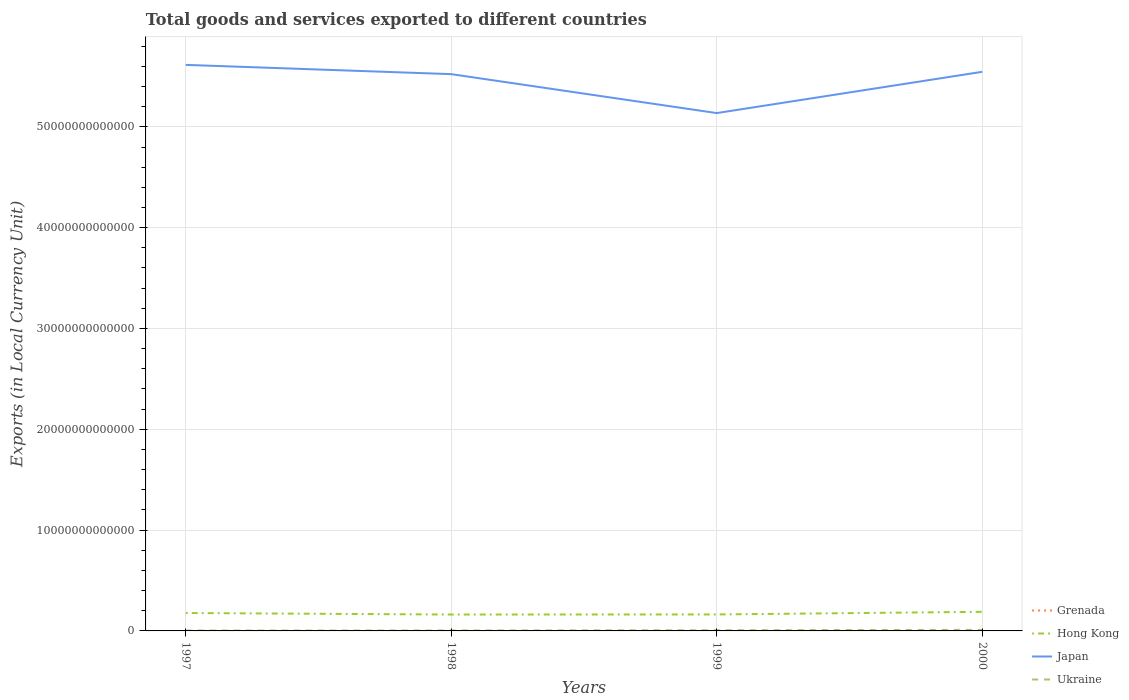Does the line corresponding to Ukraine intersect with the line corresponding to Hong Kong?
Your answer should be compact. No. Is the number of lines equal to the number of legend labels?
Provide a short and direct response. Yes. Across all years, what is the maximum Amount of goods and services exports in Ukraine?
Give a very brief answer. 3.79e+1. In which year was the Amount of goods and services exports in Japan maximum?
Your answer should be compact. 1999. What is the total Amount of goods and services exports in Ukraine in the graph?
Ensure brevity in your answer.  -6.83e+1. What is the difference between the highest and the second highest Amount of goods and services exports in Grenada?
Provide a succinct answer. 2.74e+08. Is the Amount of goods and services exports in Grenada strictly greater than the Amount of goods and services exports in Ukraine over the years?
Ensure brevity in your answer.  Yes. How many lines are there?
Keep it short and to the point. 4. What is the difference between two consecutive major ticks on the Y-axis?
Offer a very short reply. 1.00e+13. Does the graph contain grids?
Offer a very short reply. Yes. Where does the legend appear in the graph?
Your answer should be compact. Bottom right. How many legend labels are there?
Provide a succinct answer. 4. How are the legend labels stacked?
Give a very brief answer. Vertical. What is the title of the graph?
Keep it short and to the point. Total goods and services exported to different countries. Does "Croatia" appear as one of the legend labels in the graph?
Offer a terse response. No. What is the label or title of the X-axis?
Give a very brief answer. Years. What is the label or title of the Y-axis?
Offer a terse response. Exports (in Local Currency Unit). What is the Exports (in Local Currency Unit) of Grenada in 1997?
Provide a short and direct response. 3.62e+08. What is the Exports (in Local Currency Unit) in Hong Kong in 1997?
Your response must be concise. 1.78e+12. What is the Exports (in Local Currency Unit) in Japan in 1997?
Offer a very short reply. 5.61e+13. What is the Exports (in Local Currency Unit) in Ukraine in 1997?
Your answer should be compact. 3.79e+1. What is the Exports (in Local Currency Unit) of Grenada in 1998?
Your answer should be compact. 4.25e+08. What is the Exports (in Local Currency Unit) of Hong Kong in 1998?
Ensure brevity in your answer.  1.63e+12. What is the Exports (in Local Currency Unit) in Japan in 1998?
Provide a short and direct response. 5.52e+13. What is the Exports (in Local Currency Unit) of Ukraine in 1998?
Keep it short and to the point. 4.30e+1. What is the Exports (in Local Currency Unit) in Grenada in 1999?
Your answer should be very brief. 5.89e+08. What is the Exports (in Local Currency Unit) in Hong Kong in 1999?
Your answer should be compact. 1.63e+12. What is the Exports (in Local Currency Unit) of Japan in 1999?
Your answer should be very brief. 5.14e+13. What is the Exports (in Local Currency Unit) of Ukraine in 1999?
Make the answer very short. 7.01e+1. What is the Exports (in Local Currency Unit) in Grenada in 2000?
Your response must be concise. 6.36e+08. What is the Exports (in Local Currency Unit) of Hong Kong in 2000?
Ensure brevity in your answer.  1.90e+12. What is the Exports (in Local Currency Unit) of Japan in 2000?
Your response must be concise. 5.55e+13. What is the Exports (in Local Currency Unit) in Ukraine in 2000?
Make the answer very short. 1.06e+11. Across all years, what is the maximum Exports (in Local Currency Unit) in Grenada?
Provide a succinct answer. 6.36e+08. Across all years, what is the maximum Exports (in Local Currency Unit) in Hong Kong?
Offer a terse response. 1.90e+12. Across all years, what is the maximum Exports (in Local Currency Unit) in Japan?
Provide a succinct answer. 5.61e+13. Across all years, what is the maximum Exports (in Local Currency Unit) of Ukraine?
Provide a short and direct response. 1.06e+11. Across all years, what is the minimum Exports (in Local Currency Unit) in Grenada?
Make the answer very short. 3.62e+08. Across all years, what is the minimum Exports (in Local Currency Unit) of Hong Kong?
Offer a very short reply. 1.63e+12. Across all years, what is the minimum Exports (in Local Currency Unit) in Japan?
Provide a short and direct response. 5.14e+13. Across all years, what is the minimum Exports (in Local Currency Unit) of Ukraine?
Offer a very short reply. 3.79e+1. What is the total Exports (in Local Currency Unit) of Grenada in the graph?
Make the answer very short. 2.01e+09. What is the total Exports (in Local Currency Unit) in Hong Kong in the graph?
Give a very brief answer. 6.93e+12. What is the total Exports (in Local Currency Unit) of Japan in the graph?
Your answer should be compact. 2.18e+14. What is the total Exports (in Local Currency Unit) of Ukraine in the graph?
Give a very brief answer. 2.57e+11. What is the difference between the Exports (in Local Currency Unit) in Grenada in 1997 and that in 1998?
Keep it short and to the point. -6.30e+07. What is the difference between the Exports (in Local Currency Unit) of Hong Kong in 1997 and that in 1998?
Give a very brief answer. 1.50e+11. What is the difference between the Exports (in Local Currency Unit) in Japan in 1997 and that in 1998?
Offer a terse response. 9.19e+11. What is the difference between the Exports (in Local Currency Unit) in Ukraine in 1997 and that in 1998?
Give a very brief answer. -5.08e+09. What is the difference between the Exports (in Local Currency Unit) of Grenada in 1997 and that in 1999?
Ensure brevity in your answer.  -2.27e+08. What is the difference between the Exports (in Local Currency Unit) of Hong Kong in 1997 and that in 1999?
Keep it short and to the point. 1.42e+11. What is the difference between the Exports (in Local Currency Unit) in Japan in 1997 and that in 1999?
Offer a terse response. 4.78e+12. What is the difference between the Exports (in Local Currency Unit) in Ukraine in 1997 and that in 1999?
Your answer should be very brief. -3.22e+1. What is the difference between the Exports (in Local Currency Unit) of Grenada in 1997 and that in 2000?
Offer a very short reply. -2.74e+08. What is the difference between the Exports (in Local Currency Unit) in Hong Kong in 1997 and that in 2000?
Offer a very short reply. -1.20e+11. What is the difference between the Exports (in Local Currency Unit) in Japan in 1997 and that in 2000?
Offer a very short reply. 6.87e+11. What is the difference between the Exports (in Local Currency Unit) of Ukraine in 1997 and that in 2000?
Your answer should be compact. -6.83e+1. What is the difference between the Exports (in Local Currency Unit) of Grenada in 1998 and that in 1999?
Your answer should be very brief. -1.64e+08. What is the difference between the Exports (in Local Currency Unit) of Hong Kong in 1998 and that in 1999?
Ensure brevity in your answer.  -7.95e+09. What is the difference between the Exports (in Local Currency Unit) in Japan in 1998 and that in 1999?
Your answer should be compact. 3.86e+12. What is the difference between the Exports (in Local Currency Unit) of Ukraine in 1998 and that in 1999?
Keep it short and to the point. -2.71e+1. What is the difference between the Exports (in Local Currency Unit) of Grenada in 1998 and that in 2000?
Your answer should be compact. -2.11e+08. What is the difference between the Exports (in Local Currency Unit) of Hong Kong in 1998 and that in 2000?
Provide a short and direct response. -2.71e+11. What is the difference between the Exports (in Local Currency Unit) in Japan in 1998 and that in 2000?
Make the answer very short. -2.32e+11. What is the difference between the Exports (in Local Currency Unit) in Ukraine in 1998 and that in 2000?
Make the answer very short. -6.32e+1. What is the difference between the Exports (in Local Currency Unit) in Grenada in 1999 and that in 2000?
Make the answer very short. -4.78e+07. What is the difference between the Exports (in Local Currency Unit) in Hong Kong in 1999 and that in 2000?
Your answer should be compact. -2.63e+11. What is the difference between the Exports (in Local Currency Unit) in Japan in 1999 and that in 2000?
Provide a short and direct response. -4.09e+12. What is the difference between the Exports (in Local Currency Unit) in Ukraine in 1999 and that in 2000?
Give a very brief answer. -3.61e+1. What is the difference between the Exports (in Local Currency Unit) of Grenada in 1997 and the Exports (in Local Currency Unit) of Hong Kong in 1998?
Offer a very short reply. -1.63e+12. What is the difference between the Exports (in Local Currency Unit) in Grenada in 1997 and the Exports (in Local Currency Unit) in Japan in 1998?
Your response must be concise. -5.52e+13. What is the difference between the Exports (in Local Currency Unit) of Grenada in 1997 and the Exports (in Local Currency Unit) of Ukraine in 1998?
Provide a short and direct response. -4.26e+1. What is the difference between the Exports (in Local Currency Unit) in Hong Kong in 1997 and the Exports (in Local Currency Unit) in Japan in 1998?
Your answer should be very brief. -5.35e+13. What is the difference between the Exports (in Local Currency Unit) of Hong Kong in 1997 and the Exports (in Local Currency Unit) of Ukraine in 1998?
Provide a short and direct response. 1.73e+12. What is the difference between the Exports (in Local Currency Unit) of Japan in 1997 and the Exports (in Local Currency Unit) of Ukraine in 1998?
Provide a succinct answer. 5.61e+13. What is the difference between the Exports (in Local Currency Unit) of Grenada in 1997 and the Exports (in Local Currency Unit) of Hong Kong in 1999?
Offer a terse response. -1.63e+12. What is the difference between the Exports (in Local Currency Unit) in Grenada in 1997 and the Exports (in Local Currency Unit) in Japan in 1999?
Provide a short and direct response. -5.14e+13. What is the difference between the Exports (in Local Currency Unit) of Grenada in 1997 and the Exports (in Local Currency Unit) of Ukraine in 1999?
Provide a short and direct response. -6.97e+1. What is the difference between the Exports (in Local Currency Unit) in Hong Kong in 1997 and the Exports (in Local Currency Unit) in Japan in 1999?
Your response must be concise. -4.96e+13. What is the difference between the Exports (in Local Currency Unit) of Hong Kong in 1997 and the Exports (in Local Currency Unit) of Ukraine in 1999?
Provide a short and direct response. 1.71e+12. What is the difference between the Exports (in Local Currency Unit) in Japan in 1997 and the Exports (in Local Currency Unit) in Ukraine in 1999?
Provide a short and direct response. 5.61e+13. What is the difference between the Exports (in Local Currency Unit) in Grenada in 1997 and the Exports (in Local Currency Unit) in Hong Kong in 2000?
Ensure brevity in your answer.  -1.90e+12. What is the difference between the Exports (in Local Currency Unit) of Grenada in 1997 and the Exports (in Local Currency Unit) of Japan in 2000?
Your response must be concise. -5.55e+13. What is the difference between the Exports (in Local Currency Unit) of Grenada in 1997 and the Exports (in Local Currency Unit) of Ukraine in 2000?
Offer a terse response. -1.06e+11. What is the difference between the Exports (in Local Currency Unit) in Hong Kong in 1997 and the Exports (in Local Currency Unit) in Japan in 2000?
Provide a short and direct response. -5.37e+13. What is the difference between the Exports (in Local Currency Unit) in Hong Kong in 1997 and the Exports (in Local Currency Unit) in Ukraine in 2000?
Offer a terse response. 1.67e+12. What is the difference between the Exports (in Local Currency Unit) in Japan in 1997 and the Exports (in Local Currency Unit) in Ukraine in 2000?
Provide a succinct answer. 5.60e+13. What is the difference between the Exports (in Local Currency Unit) in Grenada in 1998 and the Exports (in Local Currency Unit) in Hong Kong in 1999?
Your response must be concise. -1.63e+12. What is the difference between the Exports (in Local Currency Unit) of Grenada in 1998 and the Exports (in Local Currency Unit) of Japan in 1999?
Your response must be concise. -5.14e+13. What is the difference between the Exports (in Local Currency Unit) of Grenada in 1998 and the Exports (in Local Currency Unit) of Ukraine in 1999?
Provide a succinct answer. -6.96e+1. What is the difference between the Exports (in Local Currency Unit) in Hong Kong in 1998 and the Exports (in Local Currency Unit) in Japan in 1999?
Offer a very short reply. -4.97e+13. What is the difference between the Exports (in Local Currency Unit) in Hong Kong in 1998 and the Exports (in Local Currency Unit) in Ukraine in 1999?
Your response must be concise. 1.56e+12. What is the difference between the Exports (in Local Currency Unit) in Japan in 1998 and the Exports (in Local Currency Unit) in Ukraine in 1999?
Your answer should be very brief. 5.52e+13. What is the difference between the Exports (in Local Currency Unit) in Grenada in 1998 and the Exports (in Local Currency Unit) in Hong Kong in 2000?
Provide a short and direct response. -1.90e+12. What is the difference between the Exports (in Local Currency Unit) in Grenada in 1998 and the Exports (in Local Currency Unit) in Japan in 2000?
Make the answer very short. -5.55e+13. What is the difference between the Exports (in Local Currency Unit) in Grenada in 1998 and the Exports (in Local Currency Unit) in Ukraine in 2000?
Your response must be concise. -1.06e+11. What is the difference between the Exports (in Local Currency Unit) of Hong Kong in 1998 and the Exports (in Local Currency Unit) of Japan in 2000?
Your response must be concise. -5.38e+13. What is the difference between the Exports (in Local Currency Unit) of Hong Kong in 1998 and the Exports (in Local Currency Unit) of Ukraine in 2000?
Your answer should be compact. 1.52e+12. What is the difference between the Exports (in Local Currency Unit) of Japan in 1998 and the Exports (in Local Currency Unit) of Ukraine in 2000?
Offer a terse response. 5.51e+13. What is the difference between the Exports (in Local Currency Unit) of Grenada in 1999 and the Exports (in Local Currency Unit) of Hong Kong in 2000?
Your answer should be very brief. -1.90e+12. What is the difference between the Exports (in Local Currency Unit) in Grenada in 1999 and the Exports (in Local Currency Unit) in Japan in 2000?
Offer a terse response. -5.55e+13. What is the difference between the Exports (in Local Currency Unit) of Grenada in 1999 and the Exports (in Local Currency Unit) of Ukraine in 2000?
Offer a very short reply. -1.06e+11. What is the difference between the Exports (in Local Currency Unit) in Hong Kong in 1999 and the Exports (in Local Currency Unit) in Japan in 2000?
Offer a terse response. -5.38e+13. What is the difference between the Exports (in Local Currency Unit) of Hong Kong in 1999 and the Exports (in Local Currency Unit) of Ukraine in 2000?
Ensure brevity in your answer.  1.53e+12. What is the difference between the Exports (in Local Currency Unit) of Japan in 1999 and the Exports (in Local Currency Unit) of Ukraine in 2000?
Your response must be concise. 5.13e+13. What is the average Exports (in Local Currency Unit) of Grenada per year?
Provide a short and direct response. 5.03e+08. What is the average Exports (in Local Currency Unit) in Hong Kong per year?
Your answer should be compact. 1.73e+12. What is the average Exports (in Local Currency Unit) in Japan per year?
Keep it short and to the point. 5.45e+13. What is the average Exports (in Local Currency Unit) of Ukraine per year?
Your answer should be very brief. 6.43e+1. In the year 1997, what is the difference between the Exports (in Local Currency Unit) of Grenada and Exports (in Local Currency Unit) of Hong Kong?
Make the answer very short. -1.78e+12. In the year 1997, what is the difference between the Exports (in Local Currency Unit) in Grenada and Exports (in Local Currency Unit) in Japan?
Keep it short and to the point. -5.61e+13. In the year 1997, what is the difference between the Exports (in Local Currency Unit) of Grenada and Exports (in Local Currency Unit) of Ukraine?
Ensure brevity in your answer.  -3.75e+1. In the year 1997, what is the difference between the Exports (in Local Currency Unit) in Hong Kong and Exports (in Local Currency Unit) in Japan?
Keep it short and to the point. -5.44e+13. In the year 1997, what is the difference between the Exports (in Local Currency Unit) of Hong Kong and Exports (in Local Currency Unit) of Ukraine?
Your answer should be very brief. 1.74e+12. In the year 1997, what is the difference between the Exports (in Local Currency Unit) of Japan and Exports (in Local Currency Unit) of Ukraine?
Give a very brief answer. 5.61e+13. In the year 1998, what is the difference between the Exports (in Local Currency Unit) of Grenada and Exports (in Local Currency Unit) of Hong Kong?
Offer a very short reply. -1.63e+12. In the year 1998, what is the difference between the Exports (in Local Currency Unit) in Grenada and Exports (in Local Currency Unit) in Japan?
Ensure brevity in your answer.  -5.52e+13. In the year 1998, what is the difference between the Exports (in Local Currency Unit) of Grenada and Exports (in Local Currency Unit) of Ukraine?
Provide a short and direct response. -4.25e+1. In the year 1998, what is the difference between the Exports (in Local Currency Unit) of Hong Kong and Exports (in Local Currency Unit) of Japan?
Your response must be concise. -5.36e+13. In the year 1998, what is the difference between the Exports (in Local Currency Unit) of Hong Kong and Exports (in Local Currency Unit) of Ukraine?
Provide a succinct answer. 1.58e+12. In the year 1998, what is the difference between the Exports (in Local Currency Unit) in Japan and Exports (in Local Currency Unit) in Ukraine?
Your answer should be compact. 5.52e+13. In the year 1999, what is the difference between the Exports (in Local Currency Unit) in Grenada and Exports (in Local Currency Unit) in Hong Kong?
Your response must be concise. -1.63e+12. In the year 1999, what is the difference between the Exports (in Local Currency Unit) in Grenada and Exports (in Local Currency Unit) in Japan?
Give a very brief answer. -5.14e+13. In the year 1999, what is the difference between the Exports (in Local Currency Unit) of Grenada and Exports (in Local Currency Unit) of Ukraine?
Give a very brief answer. -6.95e+1. In the year 1999, what is the difference between the Exports (in Local Currency Unit) of Hong Kong and Exports (in Local Currency Unit) of Japan?
Your response must be concise. -4.97e+13. In the year 1999, what is the difference between the Exports (in Local Currency Unit) of Hong Kong and Exports (in Local Currency Unit) of Ukraine?
Your answer should be compact. 1.56e+12. In the year 1999, what is the difference between the Exports (in Local Currency Unit) in Japan and Exports (in Local Currency Unit) in Ukraine?
Your response must be concise. 5.13e+13. In the year 2000, what is the difference between the Exports (in Local Currency Unit) in Grenada and Exports (in Local Currency Unit) in Hong Kong?
Your answer should be compact. -1.90e+12. In the year 2000, what is the difference between the Exports (in Local Currency Unit) in Grenada and Exports (in Local Currency Unit) in Japan?
Make the answer very short. -5.55e+13. In the year 2000, what is the difference between the Exports (in Local Currency Unit) in Grenada and Exports (in Local Currency Unit) in Ukraine?
Make the answer very short. -1.06e+11. In the year 2000, what is the difference between the Exports (in Local Currency Unit) of Hong Kong and Exports (in Local Currency Unit) of Japan?
Provide a succinct answer. -5.36e+13. In the year 2000, what is the difference between the Exports (in Local Currency Unit) in Hong Kong and Exports (in Local Currency Unit) in Ukraine?
Ensure brevity in your answer.  1.79e+12. In the year 2000, what is the difference between the Exports (in Local Currency Unit) of Japan and Exports (in Local Currency Unit) of Ukraine?
Give a very brief answer. 5.54e+13. What is the ratio of the Exports (in Local Currency Unit) of Grenada in 1997 to that in 1998?
Make the answer very short. 0.85. What is the ratio of the Exports (in Local Currency Unit) in Hong Kong in 1997 to that in 1998?
Give a very brief answer. 1.09. What is the ratio of the Exports (in Local Currency Unit) in Japan in 1997 to that in 1998?
Make the answer very short. 1.02. What is the ratio of the Exports (in Local Currency Unit) of Ukraine in 1997 to that in 1998?
Your response must be concise. 0.88. What is the ratio of the Exports (in Local Currency Unit) of Grenada in 1997 to that in 1999?
Offer a very short reply. 0.61. What is the ratio of the Exports (in Local Currency Unit) of Hong Kong in 1997 to that in 1999?
Offer a very short reply. 1.09. What is the ratio of the Exports (in Local Currency Unit) of Japan in 1997 to that in 1999?
Offer a very short reply. 1.09. What is the ratio of the Exports (in Local Currency Unit) in Ukraine in 1997 to that in 1999?
Offer a terse response. 0.54. What is the ratio of the Exports (in Local Currency Unit) in Grenada in 1997 to that in 2000?
Your answer should be compact. 0.57. What is the ratio of the Exports (in Local Currency Unit) in Hong Kong in 1997 to that in 2000?
Provide a succinct answer. 0.94. What is the ratio of the Exports (in Local Currency Unit) in Japan in 1997 to that in 2000?
Provide a succinct answer. 1.01. What is the ratio of the Exports (in Local Currency Unit) of Ukraine in 1997 to that in 2000?
Your answer should be compact. 0.36. What is the ratio of the Exports (in Local Currency Unit) of Grenada in 1998 to that in 1999?
Your answer should be very brief. 0.72. What is the ratio of the Exports (in Local Currency Unit) of Japan in 1998 to that in 1999?
Your answer should be very brief. 1.08. What is the ratio of the Exports (in Local Currency Unit) of Ukraine in 1998 to that in 1999?
Your response must be concise. 0.61. What is the ratio of the Exports (in Local Currency Unit) in Grenada in 1998 to that in 2000?
Your response must be concise. 0.67. What is the ratio of the Exports (in Local Currency Unit) in Hong Kong in 1998 to that in 2000?
Your answer should be very brief. 0.86. What is the ratio of the Exports (in Local Currency Unit) of Japan in 1998 to that in 2000?
Your response must be concise. 1. What is the ratio of the Exports (in Local Currency Unit) in Ukraine in 1998 to that in 2000?
Make the answer very short. 0.4. What is the ratio of the Exports (in Local Currency Unit) in Grenada in 1999 to that in 2000?
Give a very brief answer. 0.93. What is the ratio of the Exports (in Local Currency Unit) in Hong Kong in 1999 to that in 2000?
Make the answer very short. 0.86. What is the ratio of the Exports (in Local Currency Unit) in Japan in 1999 to that in 2000?
Provide a short and direct response. 0.93. What is the ratio of the Exports (in Local Currency Unit) in Ukraine in 1999 to that in 2000?
Offer a very short reply. 0.66. What is the difference between the highest and the second highest Exports (in Local Currency Unit) in Grenada?
Keep it short and to the point. 4.78e+07. What is the difference between the highest and the second highest Exports (in Local Currency Unit) of Hong Kong?
Keep it short and to the point. 1.20e+11. What is the difference between the highest and the second highest Exports (in Local Currency Unit) of Japan?
Your answer should be very brief. 6.87e+11. What is the difference between the highest and the second highest Exports (in Local Currency Unit) in Ukraine?
Give a very brief answer. 3.61e+1. What is the difference between the highest and the lowest Exports (in Local Currency Unit) in Grenada?
Keep it short and to the point. 2.74e+08. What is the difference between the highest and the lowest Exports (in Local Currency Unit) in Hong Kong?
Your answer should be compact. 2.71e+11. What is the difference between the highest and the lowest Exports (in Local Currency Unit) in Japan?
Keep it short and to the point. 4.78e+12. What is the difference between the highest and the lowest Exports (in Local Currency Unit) in Ukraine?
Offer a terse response. 6.83e+1. 